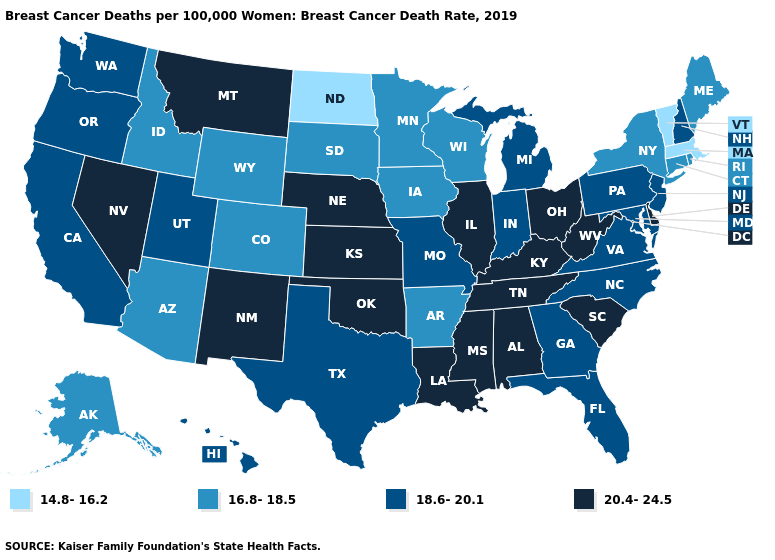Name the states that have a value in the range 16.8-18.5?
Short answer required. Alaska, Arizona, Arkansas, Colorado, Connecticut, Idaho, Iowa, Maine, Minnesota, New York, Rhode Island, South Dakota, Wisconsin, Wyoming. What is the value of Utah?
Keep it brief. 18.6-20.1. Name the states that have a value in the range 16.8-18.5?
Keep it brief. Alaska, Arizona, Arkansas, Colorado, Connecticut, Idaho, Iowa, Maine, Minnesota, New York, Rhode Island, South Dakota, Wisconsin, Wyoming. Does the map have missing data?
Concise answer only. No. What is the value of Washington?
Give a very brief answer. 18.6-20.1. Name the states that have a value in the range 18.6-20.1?
Keep it brief. California, Florida, Georgia, Hawaii, Indiana, Maryland, Michigan, Missouri, New Hampshire, New Jersey, North Carolina, Oregon, Pennsylvania, Texas, Utah, Virginia, Washington. Which states have the lowest value in the Northeast?
Write a very short answer. Massachusetts, Vermont. What is the lowest value in the Northeast?
Concise answer only. 14.8-16.2. What is the value of Iowa?
Quick response, please. 16.8-18.5. What is the value of Missouri?
Short answer required. 18.6-20.1. What is the value of Oregon?
Concise answer only. 18.6-20.1. Does Maryland have a higher value than Wisconsin?
Short answer required. Yes. What is the value of Illinois?
Keep it brief. 20.4-24.5. Among the states that border Ohio , which have the highest value?
Answer briefly. Kentucky, West Virginia. Does Arkansas have a higher value than South Carolina?
Concise answer only. No. 